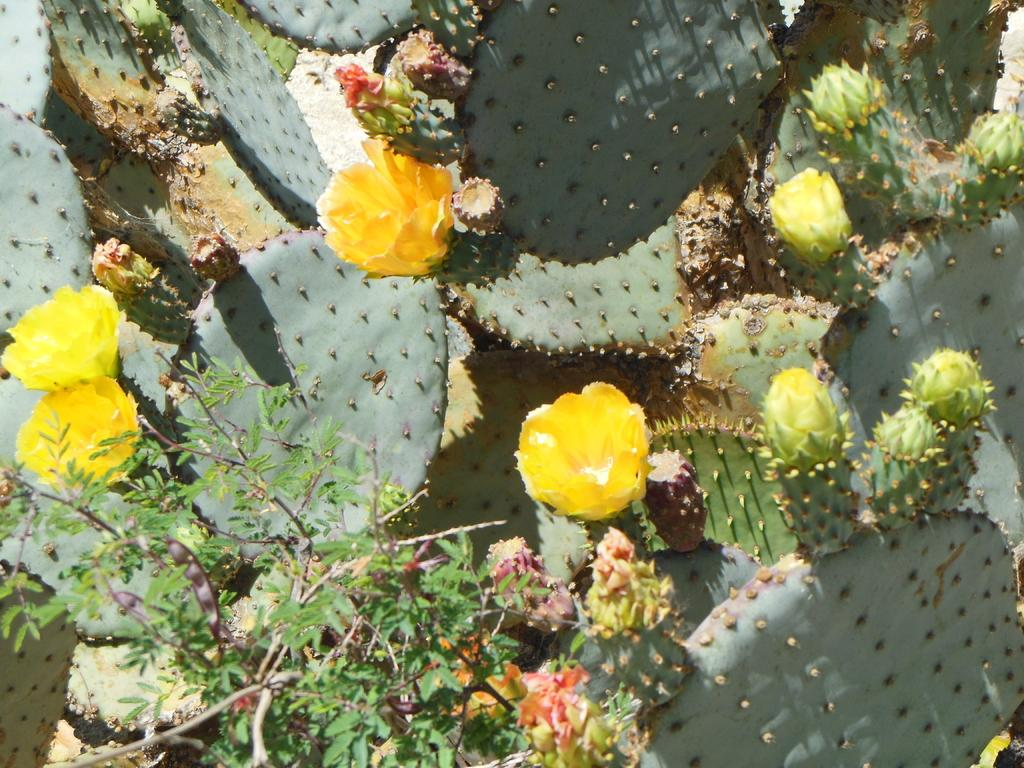What type of living organisms can be seen in the image? There are flowers and plants visible in the image. Can you describe the plants in the image? The plants in the image are not specified, but they are present alongside the flowers. How many jellyfish can be seen swimming in the image? There are no jellyfish present in the image; it features flowers and plants. What type of chalk is being used to draw on the plants in the image? There is no chalk or drawing activity present in the image. 